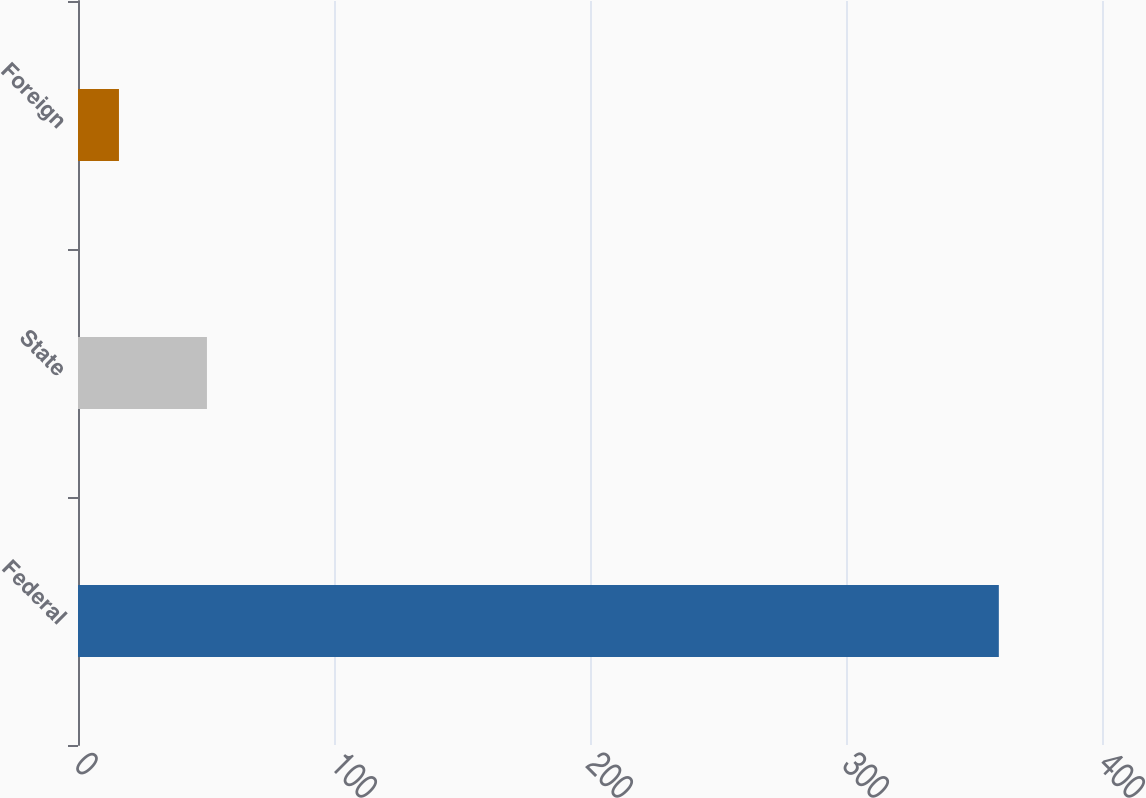Convert chart. <chart><loc_0><loc_0><loc_500><loc_500><bar_chart><fcel>Federal<fcel>State<fcel>Foreign<nl><fcel>359.7<fcel>50.37<fcel>16<nl></chart> 